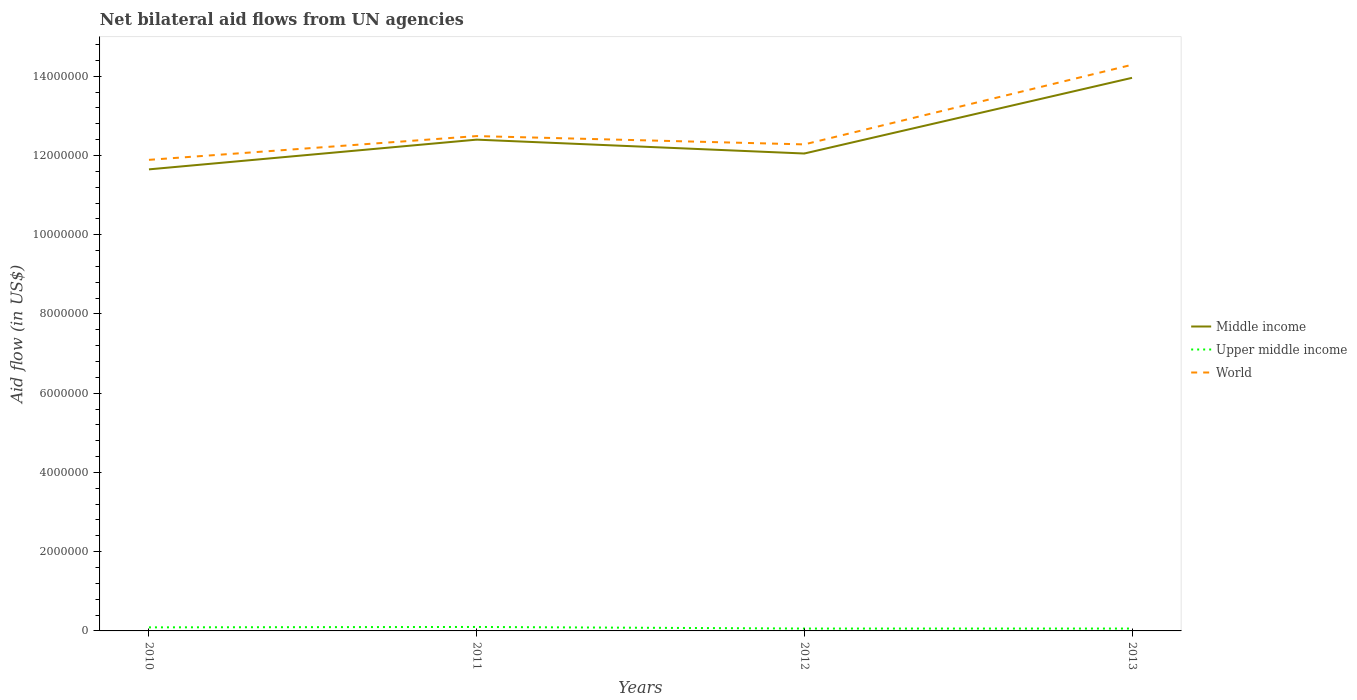Does the line corresponding to Middle income intersect with the line corresponding to Upper middle income?
Make the answer very short. No. Across all years, what is the maximum net bilateral aid flow in World?
Offer a very short reply. 1.19e+07. In which year was the net bilateral aid flow in Middle income maximum?
Your response must be concise. 2010. What is the total net bilateral aid flow in Middle income in the graph?
Provide a short and direct response. -1.91e+06. What is the difference between the highest and the second highest net bilateral aid flow in World?
Keep it short and to the point. 2.40e+06. Is the net bilateral aid flow in Middle income strictly greater than the net bilateral aid flow in Upper middle income over the years?
Your answer should be compact. No. Are the values on the major ticks of Y-axis written in scientific E-notation?
Make the answer very short. No. Where does the legend appear in the graph?
Ensure brevity in your answer.  Center right. How are the legend labels stacked?
Offer a very short reply. Vertical. What is the title of the graph?
Give a very brief answer. Net bilateral aid flows from UN agencies. What is the label or title of the Y-axis?
Your response must be concise. Aid flow (in US$). What is the Aid flow (in US$) of Middle income in 2010?
Your response must be concise. 1.16e+07. What is the Aid flow (in US$) in Upper middle income in 2010?
Offer a very short reply. 9.00e+04. What is the Aid flow (in US$) in World in 2010?
Your response must be concise. 1.19e+07. What is the Aid flow (in US$) of Middle income in 2011?
Make the answer very short. 1.24e+07. What is the Aid flow (in US$) in Upper middle income in 2011?
Offer a terse response. 1.00e+05. What is the Aid flow (in US$) of World in 2011?
Your answer should be very brief. 1.25e+07. What is the Aid flow (in US$) of Middle income in 2012?
Offer a very short reply. 1.20e+07. What is the Aid flow (in US$) in World in 2012?
Give a very brief answer. 1.23e+07. What is the Aid flow (in US$) in Middle income in 2013?
Offer a terse response. 1.40e+07. What is the Aid flow (in US$) in World in 2013?
Provide a short and direct response. 1.43e+07. Across all years, what is the maximum Aid flow (in US$) of Middle income?
Keep it short and to the point. 1.40e+07. Across all years, what is the maximum Aid flow (in US$) in Upper middle income?
Your answer should be compact. 1.00e+05. Across all years, what is the maximum Aid flow (in US$) of World?
Provide a succinct answer. 1.43e+07. Across all years, what is the minimum Aid flow (in US$) of Middle income?
Give a very brief answer. 1.16e+07. Across all years, what is the minimum Aid flow (in US$) of Upper middle income?
Your response must be concise. 6.00e+04. Across all years, what is the minimum Aid flow (in US$) of World?
Keep it short and to the point. 1.19e+07. What is the total Aid flow (in US$) of Middle income in the graph?
Provide a succinct answer. 5.01e+07. What is the total Aid flow (in US$) in World in the graph?
Provide a succinct answer. 5.10e+07. What is the difference between the Aid flow (in US$) of Middle income in 2010 and that in 2011?
Provide a succinct answer. -7.50e+05. What is the difference between the Aid flow (in US$) of World in 2010 and that in 2011?
Your response must be concise. -6.00e+05. What is the difference between the Aid flow (in US$) in Middle income in 2010 and that in 2012?
Provide a succinct answer. -4.00e+05. What is the difference between the Aid flow (in US$) of World in 2010 and that in 2012?
Ensure brevity in your answer.  -3.90e+05. What is the difference between the Aid flow (in US$) in Middle income in 2010 and that in 2013?
Make the answer very short. -2.31e+06. What is the difference between the Aid flow (in US$) in Upper middle income in 2010 and that in 2013?
Give a very brief answer. 3.00e+04. What is the difference between the Aid flow (in US$) in World in 2010 and that in 2013?
Offer a very short reply. -2.40e+06. What is the difference between the Aid flow (in US$) in Upper middle income in 2011 and that in 2012?
Your response must be concise. 4.00e+04. What is the difference between the Aid flow (in US$) of Middle income in 2011 and that in 2013?
Keep it short and to the point. -1.56e+06. What is the difference between the Aid flow (in US$) in World in 2011 and that in 2013?
Offer a very short reply. -1.80e+06. What is the difference between the Aid flow (in US$) of Middle income in 2012 and that in 2013?
Provide a succinct answer. -1.91e+06. What is the difference between the Aid flow (in US$) of World in 2012 and that in 2013?
Your answer should be very brief. -2.01e+06. What is the difference between the Aid flow (in US$) of Middle income in 2010 and the Aid flow (in US$) of Upper middle income in 2011?
Provide a short and direct response. 1.16e+07. What is the difference between the Aid flow (in US$) of Middle income in 2010 and the Aid flow (in US$) of World in 2011?
Offer a very short reply. -8.40e+05. What is the difference between the Aid flow (in US$) in Upper middle income in 2010 and the Aid flow (in US$) in World in 2011?
Your answer should be compact. -1.24e+07. What is the difference between the Aid flow (in US$) in Middle income in 2010 and the Aid flow (in US$) in Upper middle income in 2012?
Ensure brevity in your answer.  1.16e+07. What is the difference between the Aid flow (in US$) of Middle income in 2010 and the Aid flow (in US$) of World in 2012?
Provide a succinct answer. -6.30e+05. What is the difference between the Aid flow (in US$) in Upper middle income in 2010 and the Aid flow (in US$) in World in 2012?
Give a very brief answer. -1.22e+07. What is the difference between the Aid flow (in US$) of Middle income in 2010 and the Aid flow (in US$) of Upper middle income in 2013?
Your answer should be very brief. 1.16e+07. What is the difference between the Aid flow (in US$) of Middle income in 2010 and the Aid flow (in US$) of World in 2013?
Provide a succinct answer. -2.64e+06. What is the difference between the Aid flow (in US$) in Upper middle income in 2010 and the Aid flow (in US$) in World in 2013?
Give a very brief answer. -1.42e+07. What is the difference between the Aid flow (in US$) in Middle income in 2011 and the Aid flow (in US$) in Upper middle income in 2012?
Your answer should be very brief. 1.23e+07. What is the difference between the Aid flow (in US$) of Upper middle income in 2011 and the Aid flow (in US$) of World in 2012?
Provide a short and direct response. -1.22e+07. What is the difference between the Aid flow (in US$) of Middle income in 2011 and the Aid flow (in US$) of Upper middle income in 2013?
Provide a short and direct response. 1.23e+07. What is the difference between the Aid flow (in US$) in Middle income in 2011 and the Aid flow (in US$) in World in 2013?
Provide a short and direct response. -1.89e+06. What is the difference between the Aid flow (in US$) of Upper middle income in 2011 and the Aid flow (in US$) of World in 2013?
Give a very brief answer. -1.42e+07. What is the difference between the Aid flow (in US$) of Middle income in 2012 and the Aid flow (in US$) of Upper middle income in 2013?
Your answer should be very brief. 1.20e+07. What is the difference between the Aid flow (in US$) in Middle income in 2012 and the Aid flow (in US$) in World in 2013?
Offer a very short reply. -2.24e+06. What is the difference between the Aid flow (in US$) of Upper middle income in 2012 and the Aid flow (in US$) of World in 2013?
Your response must be concise. -1.42e+07. What is the average Aid flow (in US$) of Middle income per year?
Your answer should be compact. 1.25e+07. What is the average Aid flow (in US$) of Upper middle income per year?
Your response must be concise. 7.75e+04. What is the average Aid flow (in US$) in World per year?
Give a very brief answer. 1.27e+07. In the year 2010, what is the difference between the Aid flow (in US$) of Middle income and Aid flow (in US$) of Upper middle income?
Offer a terse response. 1.16e+07. In the year 2010, what is the difference between the Aid flow (in US$) in Upper middle income and Aid flow (in US$) in World?
Your answer should be very brief. -1.18e+07. In the year 2011, what is the difference between the Aid flow (in US$) of Middle income and Aid flow (in US$) of Upper middle income?
Your answer should be compact. 1.23e+07. In the year 2011, what is the difference between the Aid flow (in US$) of Upper middle income and Aid flow (in US$) of World?
Provide a succinct answer. -1.24e+07. In the year 2012, what is the difference between the Aid flow (in US$) in Middle income and Aid flow (in US$) in Upper middle income?
Keep it short and to the point. 1.20e+07. In the year 2012, what is the difference between the Aid flow (in US$) of Middle income and Aid flow (in US$) of World?
Ensure brevity in your answer.  -2.30e+05. In the year 2012, what is the difference between the Aid flow (in US$) of Upper middle income and Aid flow (in US$) of World?
Your answer should be compact. -1.22e+07. In the year 2013, what is the difference between the Aid flow (in US$) of Middle income and Aid flow (in US$) of Upper middle income?
Give a very brief answer. 1.39e+07. In the year 2013, what is the difference between the Aid flow (in US$) in Middle income and Aid flow (in US$) in World?
Keep it short and to the point. -3.30e+05. In the year 2013, what is the difference between the Aid flow (in US$) of Upper middle income and Aid flow (in US$) of World?
Your response must be concise. -1.42e+07. What is the ratio of the Aid flow (in US$) in Middle income in 2010 to that in 2011?
Make the answer very short. 0.94. What is the ratio of the Aid flow (in US$) in Middle income in 2010 to that in 2012?
Your answer should be very brief. 0.97. What is the ratio of the Aid flow (in US$) in Upper middle income in 2010 to that in 2012?
Offer a very short reply. 1.5. What is the ratio of the Aid flow (in US$) of World in 2010 to that in 2012?
Provide a succinct answer. 0.97. What is the ratio of the Aid flow (in US$) in Middle income in 2010 to that in 2013?
Ensure brevity in your answer.  0.83. What is the ratio of the Aid flow (in US$) in World in 2010 to that in 2013?
Offer a very short reply. 0.83. What is the ratio of the Aid flow (in US$) of Upper middle income in 2011 to that in 2012?
Offer a very short reply. 1.67. What is the ratio of the Aid flow (in US$) of World in 2011 to that in 2012?
Give a very brief answer. 1.02. What is the ratio of the Aid flow (in US$) of Middle income in 2011 to that in 2013?
Your answer should be compact. 0.89. What is the ratio of the Aid flow (in US$) in Upper middle income in 2011 to that in 2013?
Ensure brevity in your answer.  1.67. What is the ratio of the Aid flow (in US$) in World in 2011 to that in 2013?
Give a very brief answer. 0.87. What is the ratio of the Aid flow (in US$) in Middle income in 2012 to that in 2013?
Your answer should be compact. 0.86. What is the ratio of the Aid flow (in US$) in Upper middle income in 2012 to that in 2013?
Keep it short and to the point. 1. What is the ratio of the Aid flow (in US$) of World in 2012 to that in 2013?
Ensure brevity in your answer.  0.86. What is the difference between the highest and the second highest Aid flow (in US$) in Middle income?
Your answer should be compact. 1.56e+06. What is the difference between the highest and the second highest Aid flow (in US$) in World?
Offer a terse response. 1.80e+06. What is the difference between the highest and the lowest Aid flow (in US$) in Middle income?
Your response must be concise. 2.31e+06. What is the difference between the highest and the lowest Aid flow (in US$) of World?
Keep it short and to the point. 2.40e+06. 